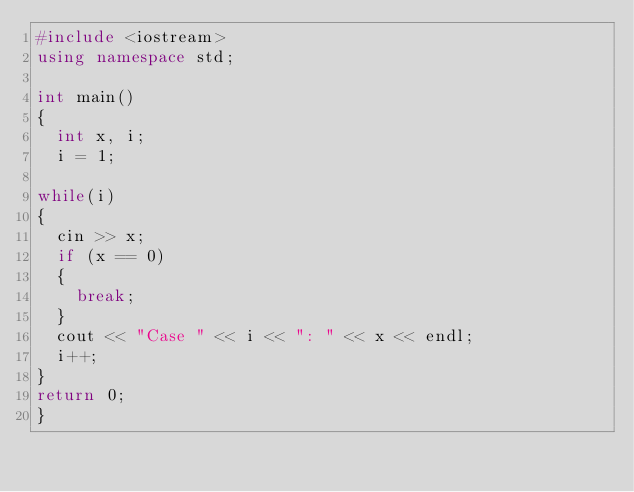<code> <loc_0><loc_0><loc_500><loc_500><_C++_>#include <iostream>
using namespace std;

int main()
{
	int x, i;
	i = 1;

while(i)
{
	cin >> x;
	if (x == 0)
	{
		break;
	}
	cout << "Case " << i << ": " << x << endl;
	i++;
}
return 0;
}</code> 